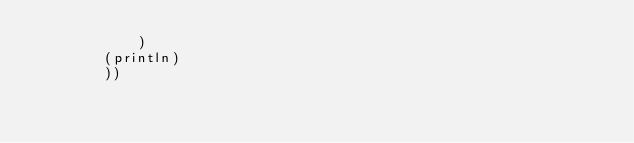Convert code to text. <code><loc_0><loc_0><loc_500><loc_500><_Clojure_>			)
		(println)
		))</code> 